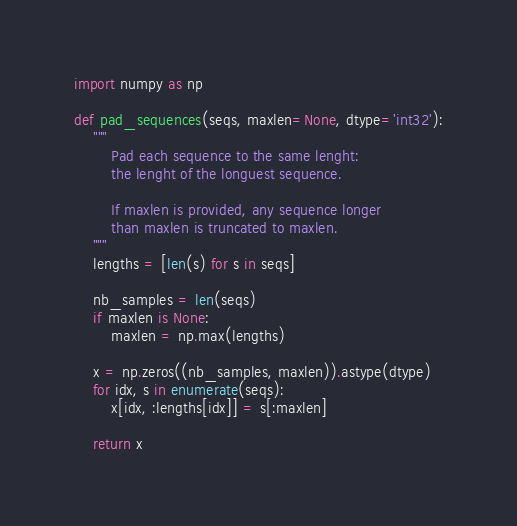<code> <loc_0><loc_0><loc_500><loc_500><_Python_>import numpy as np

def pad_sequences(seqs, maxlen=None, dtype='int32'):
    """
        Pad each sequence to the same lenght: 
        the lenght of the longuest sequence.

        If maxlen is provided, any sequence longer
        than maxlen is truncated to maxlen.
    """
    lengths = [len(s) for s in seqs]

    nb_samples = len(seqs)
    if maxlen is None:
        maxlen = np.max(lengths)

    x = np.zeros((nb_samples, maxlen)).astype(dtype)
    for idx, s in enumerate(seqs):
        x[idx, :lengths[idx]] = s[:maxlen]

    return x</code> 